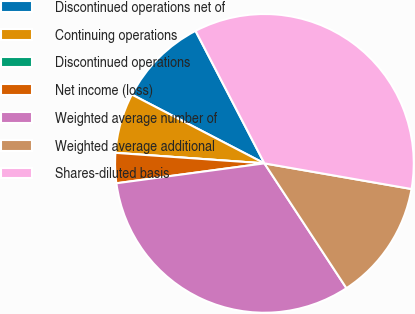Convert chart. <chart><loc_0><loc_0><loc_500><loc_500><pie_chart><fcel>Discontinued operations net of<fcel>Continuing operations<fcel>Discontinued operations<fcel>Net income (loss)<fcel>Weighted average number of<fcel>Weighted average additional<fcel>Shares-diluted basis<nl><fcel>9.75%<fcel>6.5%<fcel>0.0%<fcel>3.25%<fcel>32.13%<fcel>13.0%<fcel>35.38%<nl></chart> 